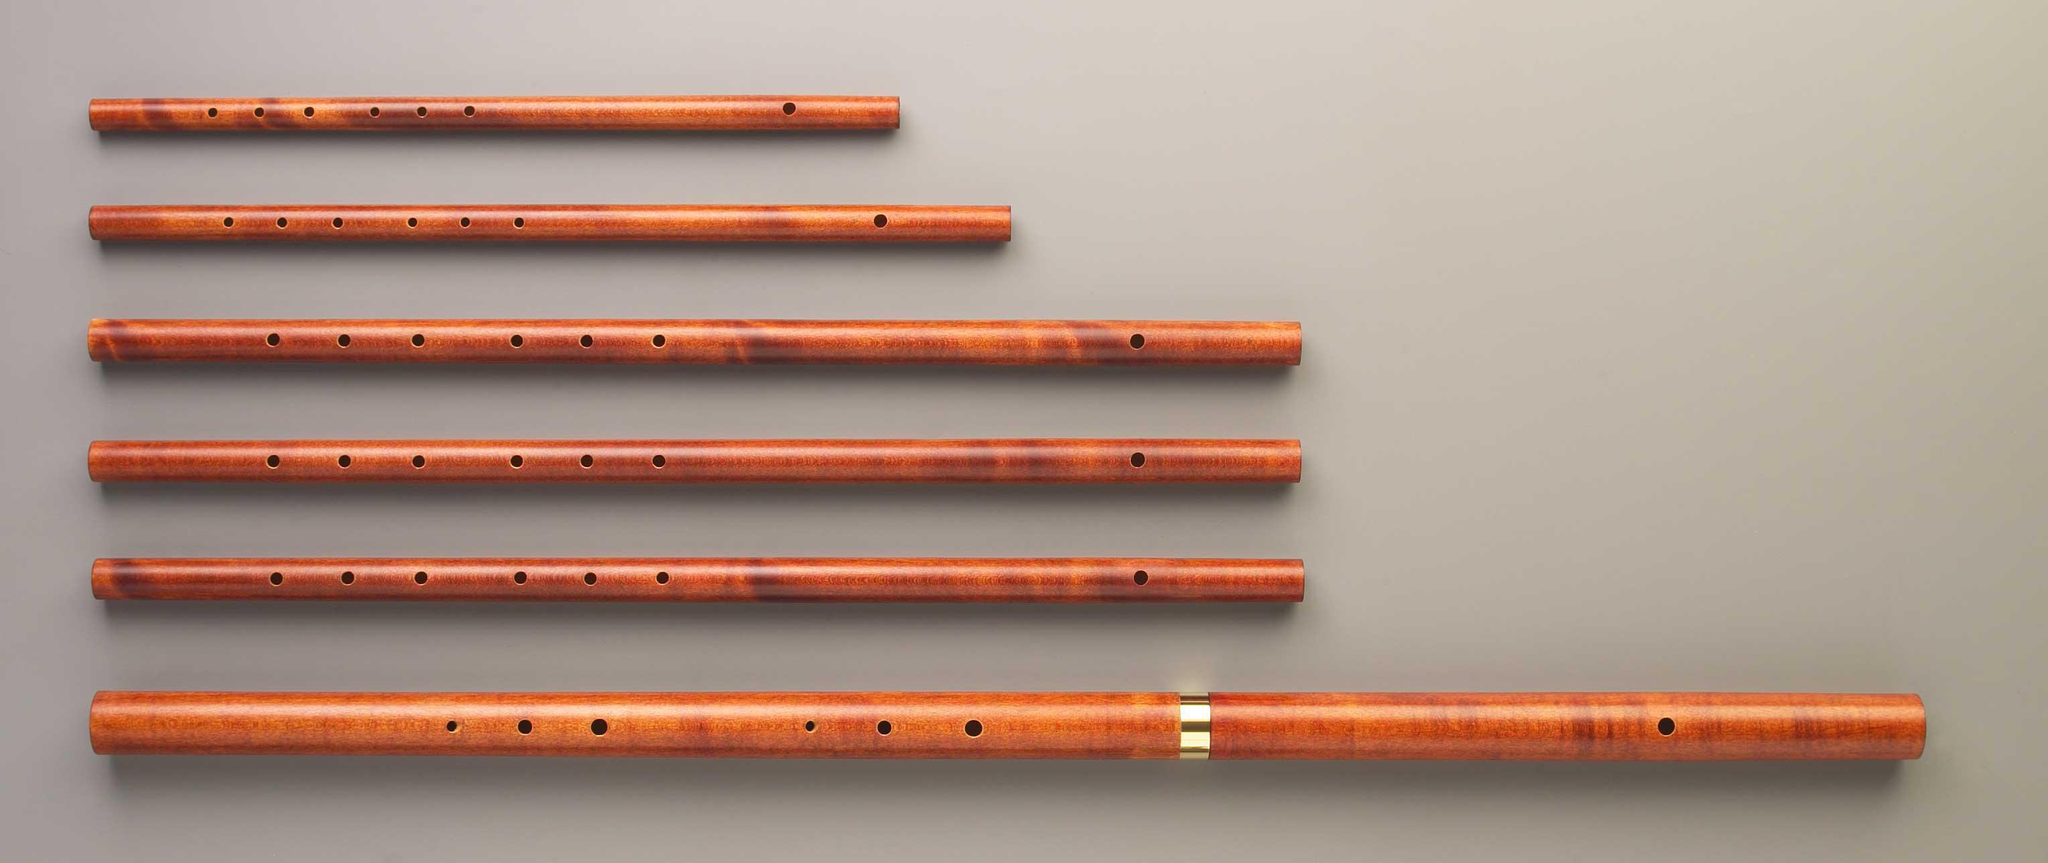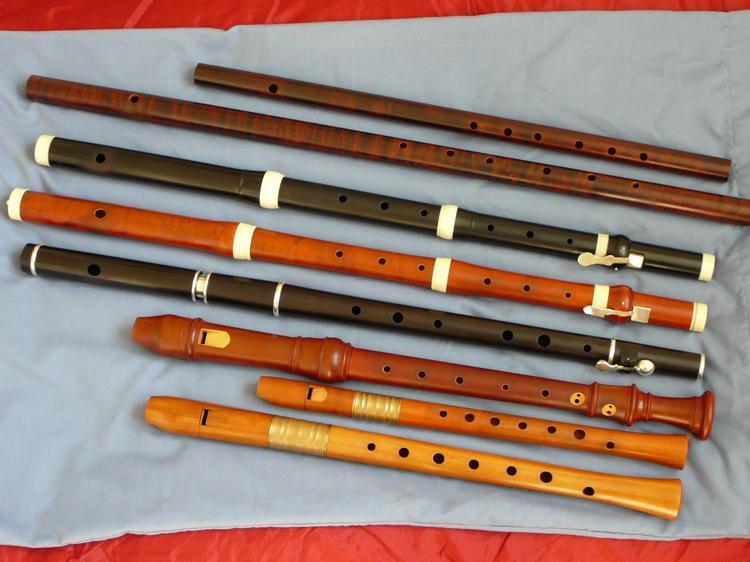The first image is the image on the left, the second image is the image on the right. Considering the images on both sides, is "The flutes in one of the images are arranged with top to bottom from smallest to largest." valid? Answer yes or no. Yes. 